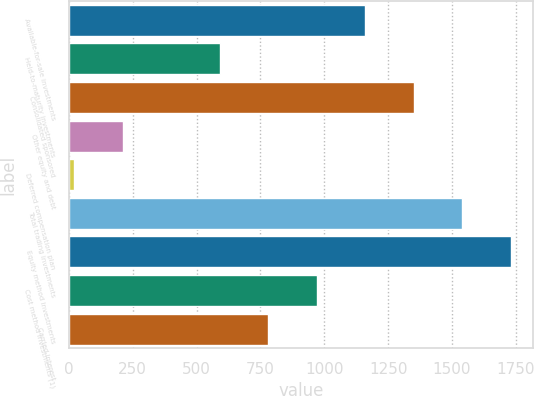Convert chart to OTSL. <chart><loc_0><loc_0><loc_500><loc_500><bar_chart><fcel>Available-for-sale investments<fcel>Held-to-maturity investments<fcel>Consolidated sponsored<fcel>Other equity and debt<fcel>Deferred compensation plan<fcel>Total trading investments<fcel>Equity method investments<fcel>Cost method investments (1)<fcel>Carried interest<nl><fcel>1161<fcel>591<fcel>1351<fcel>211<fcel>21<fcel>1541<fcel>1731<fcel>971<fcel>781<nl></chart> 